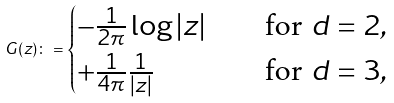Convert formula to latex. <formula><loc_0><loc_0><loc_500><loc_500>G ( z ) \colon = \begin{cases} - \frac { 1 } { 2 \pi } \log | z | \quad & \text {for } d = 2 , \\ + \frac { 1 } { 4 \pi } \frac { 1 } { | z | } \quad & \text {for } d = 3 , \end{cases}</formula> 